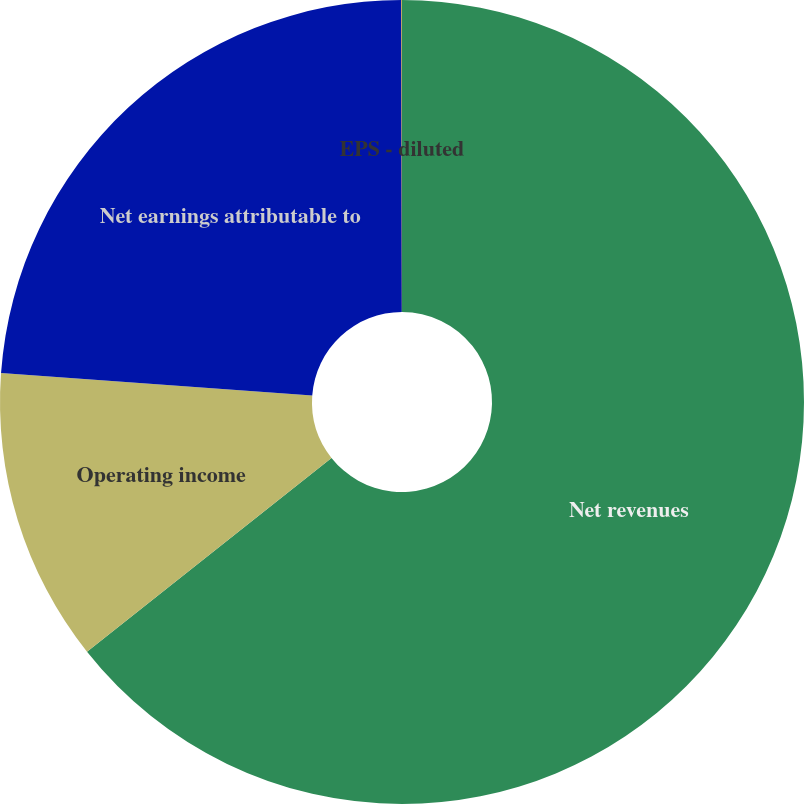Convert chart. <chart><loc_0><loc_0><loc_500><loc_500><pie_chart><fcel>Net revenues<fcel>Operating income<fcel>Net earnings attributable to<fcel>EPS - diluted<nl><fcel>64.33%<fcel>11.82%<fcel>23.83%<fcel>0.02%<nl></chart> 